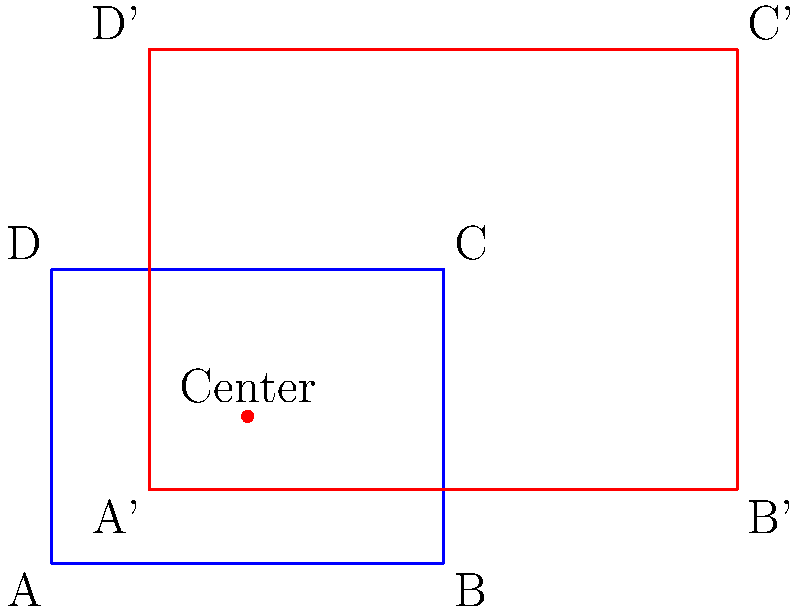In your Python coding club, you're working on a project involving transformational geometry. You have a rectangle ABCD with dimensions 4x3 units. The rectangle is scaled by a factor of 1.5 from the center point (2, 1.5). Calculate the new dimensions of the scaled rectangle A'B'C'D'. Let's approach this step-by-step:

1) First, we need to understand what scaling from a center point means. When we scale from a point, the distance of each point from the center is multiplied by the scale factor.

2) The scale factor is 1.5, and the center point is (2, 1.5).

3) To find the new dimensions, we need to calculate how much the width and height change:

   For the width:
   - The original width is 4 units.
   - The distance from the center to each side is 2 units (half the width).
   - This distance will be multiplied by 1.5: $2 * 1.5 = 3$ units
   - So the new width will be $3 + 3 = 6$ units

   For the height:
   - The original height is 3 units.
   - The distance from the center to top/bottom is 1.5 units (half the height).
   - This distance will be multiplied by 1.5: $1.5 * 1.5 = 2.25$ units
   - So the new height will be $2.25 + 2.25 = 4.5$ units

4) Therefore, the new dimensions of the scaled rectangle A'B'C'D' are 6x4.5 units.
Answer: 6x4.5 units 